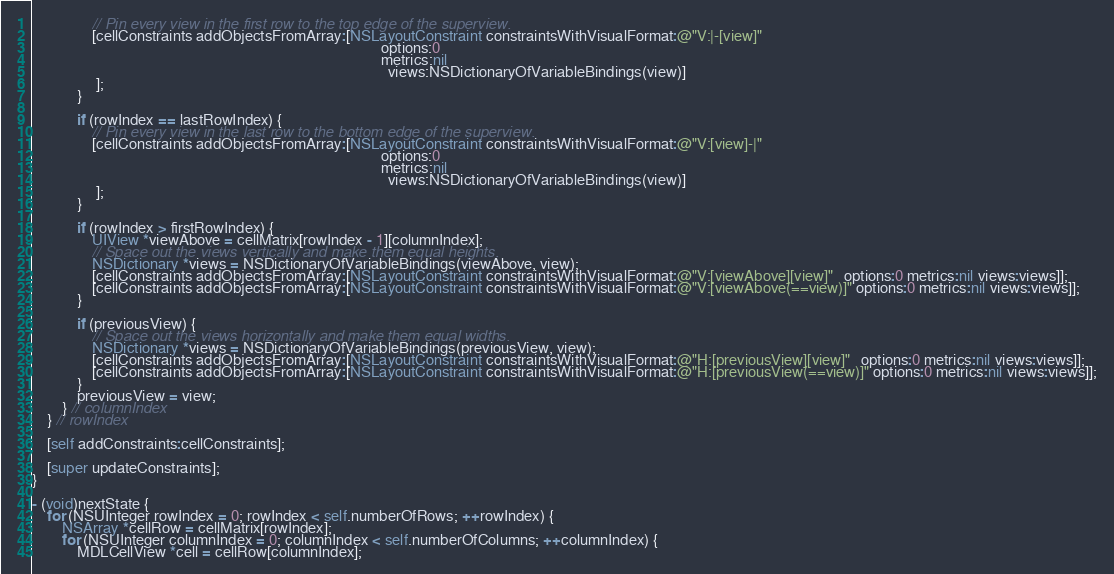Convert code to text. <code><loc_0><loc_0><loc_500><loc_500><_ObjectiveC_>                // Pin every view in the first row to the top edge of the superview.
                [cellConstraints addObjectsFromArray:[NSLayoutConstraint constraintsWithVisualFormat:@"V:|-[view]"
                                                                                             options:0
                                                                                             metrics:nil
                                                                                               views:NSDictionaryOfVariableBindings(view)]
                 ];
            }
            
            if (rowIndex == lastRowIndex) {
                // Pin every view in the last row to the bottom edge of the superview.
                [cellConstraints addObjectsFromArray:[NSLayoutConstraint constraintsWithVisualFormat:@"V:[view]-|"
                                                                                             options:0
                                                                                             metrics:nil
                                                                                               views:NSDictionaryOfVariableBindings(view)]
                 ];
            }
            
            if (rowIndex > firstRowIndex) {
                UIView *viewAbove = cellMatrix[rowIndex - 1][columnIndex];
                // Space out the views vertically and make them equal heights.
                NSDictionary *views = NSDictionaryOfVariableBindings(viewAbove, view);
                [cellConstraints addObjectsFromArray:[NSLayoutConstraint constraintsWithVisualFormat:@"V:[viewAbove][view]"   options:0 metrics:nil views:views]];
                [cellConstraints addObjectsFromArray:[NSLayoutConstraint constraintsWithVisualFormat:@"V:[viewAbove(==view)]" options:0 metrics:nil views:views]];
            }
            
            if (previousView) {
                // Space out the views horizontally and make them equal widths.
                NSDictionary *views = NSDictionaryOfVariableBindings(previousView, view);
                [cellConstraints addObjectsFromArray:[NSLayoutConstraint constraintsWithVisualFormat:@"H:[previousView][view]"   options:0 metrics:nil views:views]];
                [cellConstraints addObjectsFromArray:[NSLayoutConstraint constraintsWithVisualFormat:@"H:[previousView(==view)]" options:0 metrics:nil views:views]];
            }
            previousView = view;
        } // columnIndex
    } // rowIndex
    
    [self addConstraints:cellConstraints];

    [super updateConstraints];
}

- (void)nextState {
    for (NSUInteger rowIndex = 0; rowIndex < self.numberOfRows; ++rowIndex) {
        NSArray *cellRow = cellMatrix[rowIndex];
        for (NSUInteger columnIndex = 0; columnIndex < self.numberOfColumns; ++columnIndex) {
            MDLCellView *cell = cellRow[columnIndex];</code> 